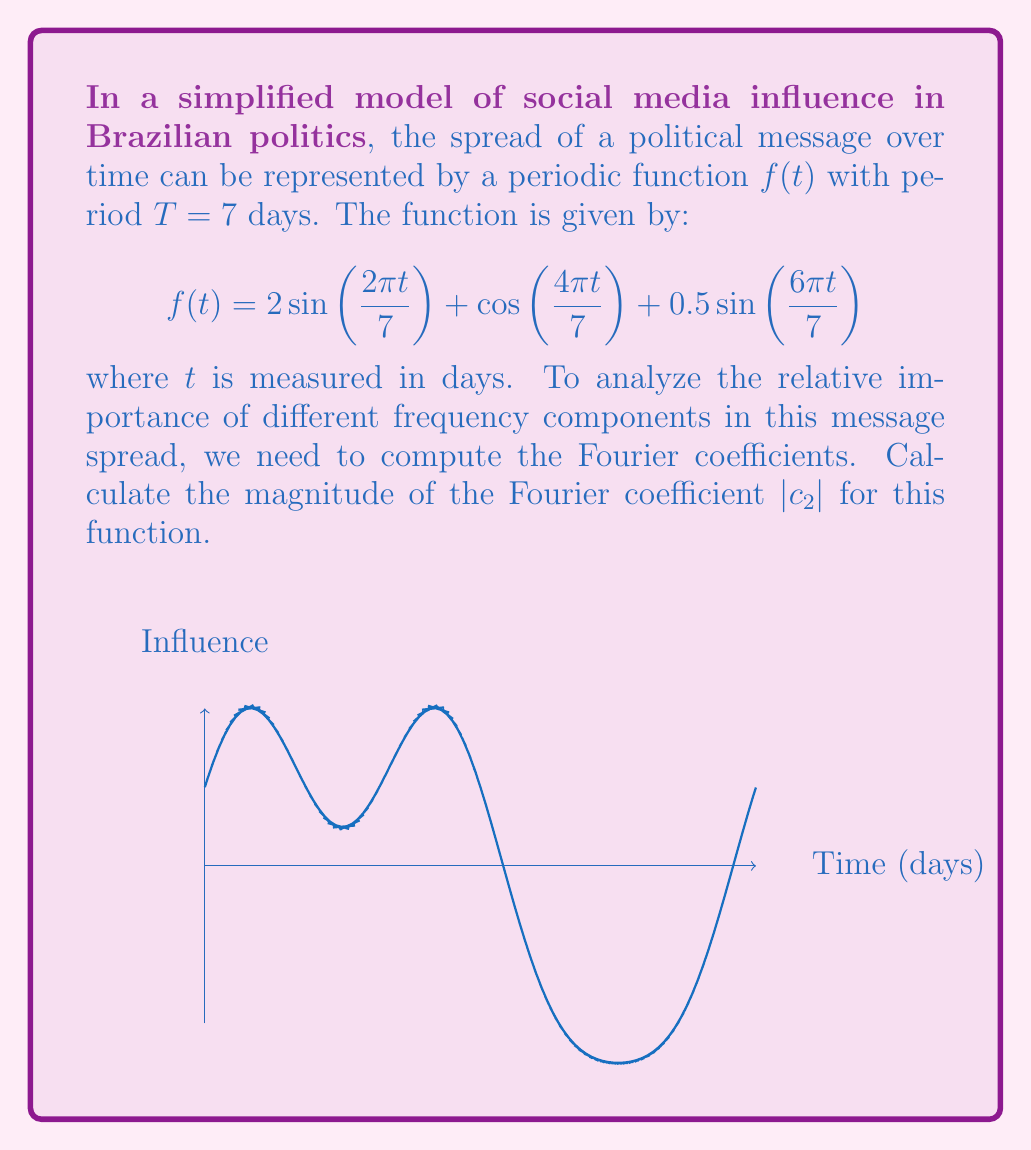Show me your answer to this math problem. Let's approach this step-by-step:

1) The general formula for Fourier coefficients $c_n$ is:

   $$c_n = \frac{1}{T} \int_0^T f(t) e^{-i\frac{2\pi nt}{T}} dt$$

2) In our case, $T=7$ and $n=2$. We need to calculate:

   $$c_2 = \frac{1}{7} \int_0^7 (2\sin(\frac{2\pi t}{7}) + \cos(\frac{4\pi t}{7}) + 0.5\sin(\frac{6\pi t}{7})) e^{-i\frac{4\pi t}{7}} dt$$

3) We can split this into three integrals:

   $$c_2 = \frac{2}{7} \int_0^7 \sin(\frac{2\pi t}{7}) e^{-i\frac{4\pi t}{7}} dt + \frac{1}{7} \int_0^7 \cos(\frac{4\pi t}{7}) e^{-i\frac{4\pi t}{7}} dt + \frac{0.5}{7} \int_0^7 \sin(\frac{6\pi t}{7}) e^{-i\frac{4\pi t}{7}} dt$$

4) Using Euler's formula and trigonometric identities, we can simplify:

   - $\int_0^7 \sin(\frac{2\pi t}{7}) e^{-i\frac{4\pi t}{7}} dt = 0$ (orthogonality of sines)
   - $\int_0^7 \cos(\frac{4\pi t}{7}) e^{-i\frac{4\pi t}{7}} dt = \frac{7}{2}$ (cosine matches the exponential)
   - $\int_0^7 \sin(\frac{6\pi t}{7}) e^{-i\frac{4\pi t}{7}} dt = 0$ (orthogonality of sines)

5) Therefore:

   $$c_2 = \frac{1}{7} \cdot \frac{7}{2} = \frac{1}{2}$$

6) The magnitude of $c_2$ is its absolute value:

   $$|c_2| = |\frac{1}{2}| = \frac{1}{2}$$
Answer: $\frac{1}{2}$ 